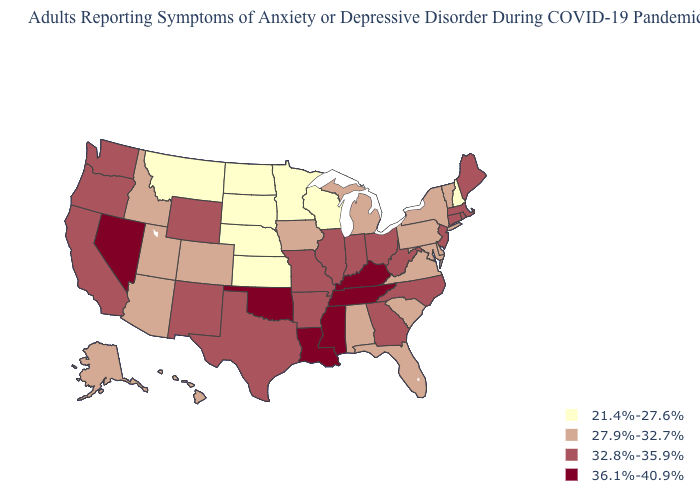Does Oklahoma have the highest value in the South?
Be succinct. Yes. Is the legend a continuous bar?
Give a very brief answer. No. Name the states that have a value in the range 32.8%-35.9%?
Give a very brief answer. Arkansas, California, Connecticut, Georgia, Illinois, Indiana, Maine, Massachusetts, Missouri, New Jersey, New Mexico, North Carolina, Ohio, Oregon, Rhode Island, Texas, Washington, West Virginia, Wyoming. Is the legend a continuous bar?
Answer briefly. No. Which states have the highest value in the USA?
Short answer required. Kentucky, Louisiana, Mississippi, Nevada, Oklahoma, Tennessee. Among the states that border Delaware , does New Jersey have the highest value?
Short answer required. Yes. Does the map have missing data?
Keep it brief. No. Does Kentucky have the same value as Tennessee?
Give a very brief answer. Yes. Which states have the lowest value in the West?
Short answer required. Montana. Does Michigan have the highest value in the USA?
Concise answer only. No. Name the states that have a value in the range 36.1%-40.9%?
Answer briefly. Kentucky, Louisiana, Mississippi, Nevada, Oklahoma, Tennessee. Does Alaska have the lowest value in the USA?
Write a very short answer. No. Name the states that have a value in the range 32.8%-35.9%?
Keep it brief. Arkansas, California, Connecticut, Georgia, Illinois, Indiana, Maine, Massachusetts, Missouri, New Jersey, New Mexico, North Carolina, Ohio, Oregon, Rhode Island, Texas, Washington, West Virginia, Wyoming. Does Mississippi have the highest value in the USA?
Write a very short answer. Yes. Name the states that have a value in the range 27.9%-32.7%?
Concise answer only. Alabama, Alaska, Arizona, Colorado, Delaware, Florida, Hawaii, Idaho, Iowa, Maryland, Michigan, New York, Pennsylvania, South Carolina, Utah, Vermont, Virginia. 